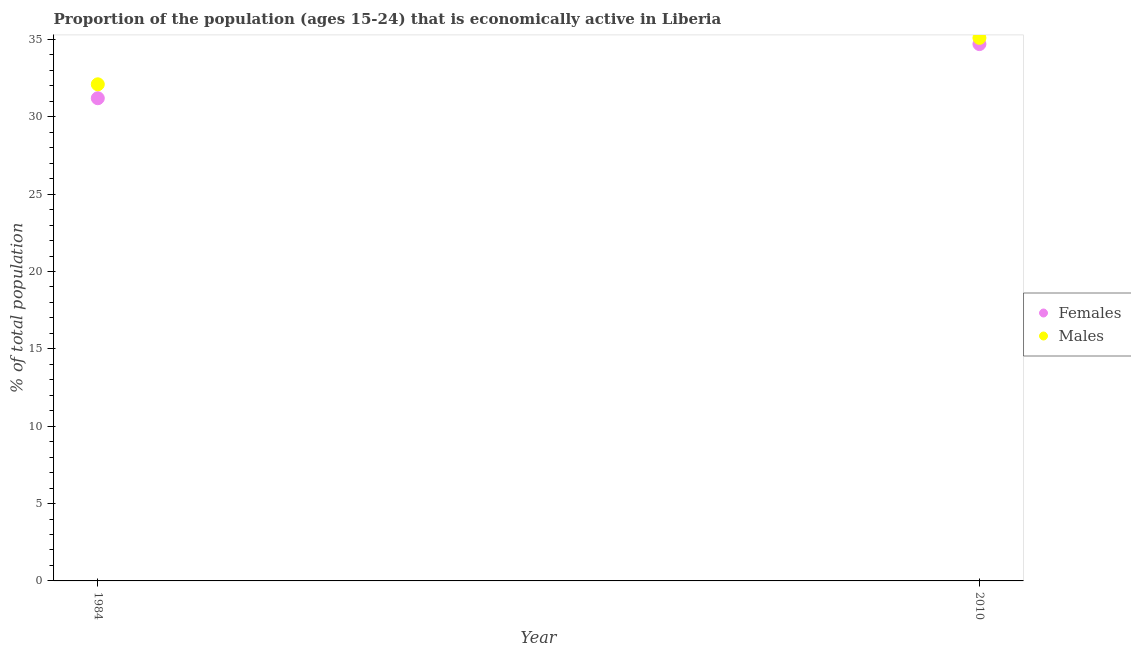How many different coloured dotlines are there?
Your answer should be compact. 2. Is the number of dotlines equal to the number of legend labels?
Provide a succinct answer. Yes. What is the percentage of economically active female population in 2010?
Provide a short and direct response. 34.7. Across all years, what is the maximum percentage of economically active male population?
Your answer should be very brief. 35.1. Across all years, what is the minimum percentage of economically active female population?
Your answer should be compact. 31.2. In which year was the percentage of economically active female population maximum?
Make the answer very short. 2010. What is the total percentage of economically active male population in the graph?
Offer a very short reply. 67.2. What is the difference between the percentage of economically active male population in 2010 and the percentage of economically active female population in 1984?
Your response must be concise. 3.9. What is the average percentage of economically active female population per year?
Provide a succinct answer. 32.95. In the year 2010, what is the difference between the percentage of economically active female population and percentage of economically active male population?
Provide a succinct answer. -0.4. What is the ratio of the percentage of economically active male population in 1984 to that in 2010?
Provide a short and direct response. 0.91. Is the percentage of economically active female population in 1984 less than that in 2010?
Make the answer very short. Yes. Does the percentage of economically active male population monotonically increase over the years?
Provide a succinct answer. Yes. Is the percentage of economically active female population strictly less than the percentage of economically active male population over the years?
Keep it short and to the point. Yes. Are the values on the major ticks of Y-axis written in scientific E-notation?
Your answer should be compact. No. Does the graph contain any zero values?
Make the answer very short. No. Does the graph contain grids?
Give a very brief answer. No. Where does the legend appear in the graph?
Provide a short and direct response. Center right. How many legend labels are there?
Provide a short and direct response. 2. What is the title of the graph?
Provide a succinct answer. Proportion of the population (ages 15-24) that is economically active in Liberia. What is the label or title of the X-axis?
Provide a succinct answer. Year. What is the label or title of the Y-axis?
Your response must be concise. % of total population. What is the % of total population of Females in 1984?
Offer a very short reply. 31.2. What is the % of total population in Males in 1984?
Offer a terse response. 32.1. What is the % of total population in Females in 2010?
Give a very brief answer. 34.7. What is the % of total population of Males in 2010?
Provide a short and direct response. 35.1. Across all years, what is the maximum % of total population of Females?
Ensure brevity in your answer.  34.7. Across all years, what is the maximum % of total population of Males?
Keep it short and to the point. 35.1. Across all years, what is the minimum % of total population in Females?
Keep it short and to the point. 31.2. Across all years, what is the minimum % of total population in Males?
Your answer should be very brief. 32.1. What is the total % of total population of Females in the graph?
Ensure brevity in your answer.  65.9. What is the total % of total population in Males in the graph?
Provide a succinct answer. 67.2. What is the difference between the % of total population in Males in 1984 and that in 2010?
Give a very brief answer. -3. What is the average % of total population in Females per year?
Provide a succinct answer. 32.95. What is the average % of total population in Males per year?
Make the answer very short. 33.6. What is the ratio of the % of total population of Females in 1984 to that in 2010?
Your response must be concise. 0.9. What is the ratio of the % of total population of Males in 1984 to that in 2010?
Provide a succinct answer. 0.91. What is the difference between the highest and the second highest % of total population in Females?
Your response must be concise. 3.5. What is the difference between the highest and the second highest % of total population in Males?
Your response must be concise. 3. What is the difference between the highest and the lowest % of total population of Males?
Your response must be concise. 3. 